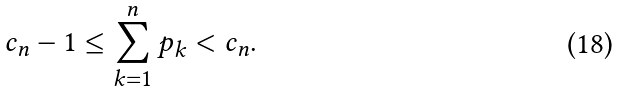Convert formula to latex. <formula><loc_0><loc_0><loc_500><loc_500>c _ { n } - 1 \leq \sum _ { k = 1 } ^ { n } p _ { k } < c _ { n } .</formula> 